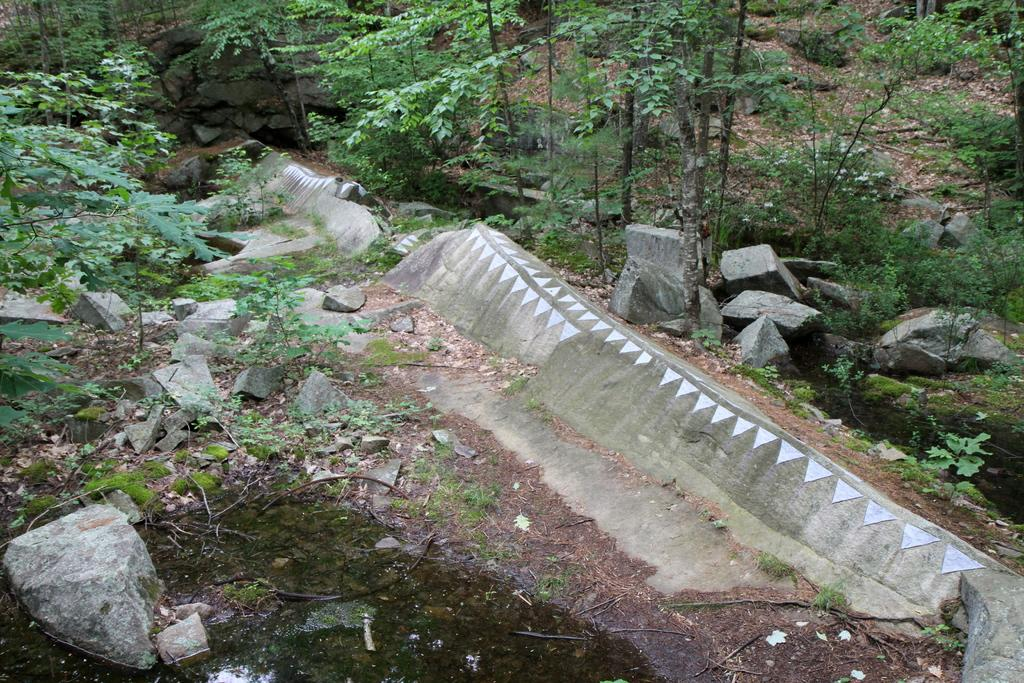What type of terrain is depicted in the image? The image shows small rocks, algae, plants, trees, and grass on the ground. Can you describe the vegetation in the image? There are plants and trees visible in the image. What is the ground covered with in the image? The ground is covered with small rocks, grass, and algae. What is present at the bottom of the image? There is water at the bottom of the image. What type of ornament is hanging from the tree in the image? There is no ornament hanging from the tree in the image; it only shows plants, trees, and rocks. How many apples can be seen on the ground in the image? There are no apples present in the image. 